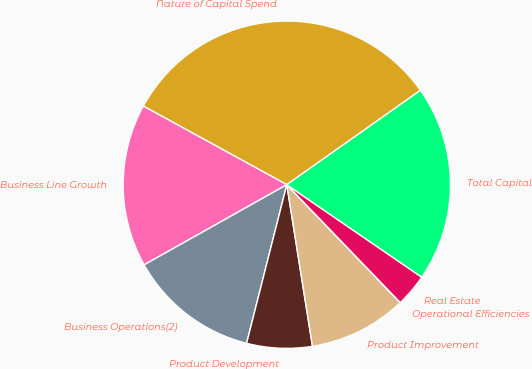Convert chart. <chart><loc_0><loc_0><loc_500><loc_500><pie_chart><fcel>Nature of Capital Spend<fcel>Business Line Growth<fcel>Business Operations(2)<fcel>Product Development<fcel>Product Improvement<fcel>Operational Efficiencies<fcel>Real Estate<fcel>Total Capital<nl><fcel>32.24%<fcel>16.13%<fcel>12.9%<fcel>6.46%<fcel>9.68%<fcel>0.01%<fcel>3.24%<fcel>19.35%<nl></chart> 